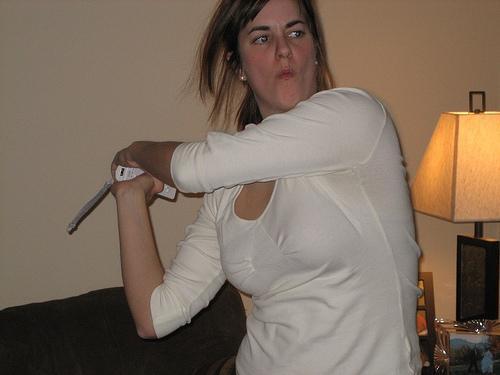How many Wii Remotes is the woman holding?
Give a very brief answer. 1. 